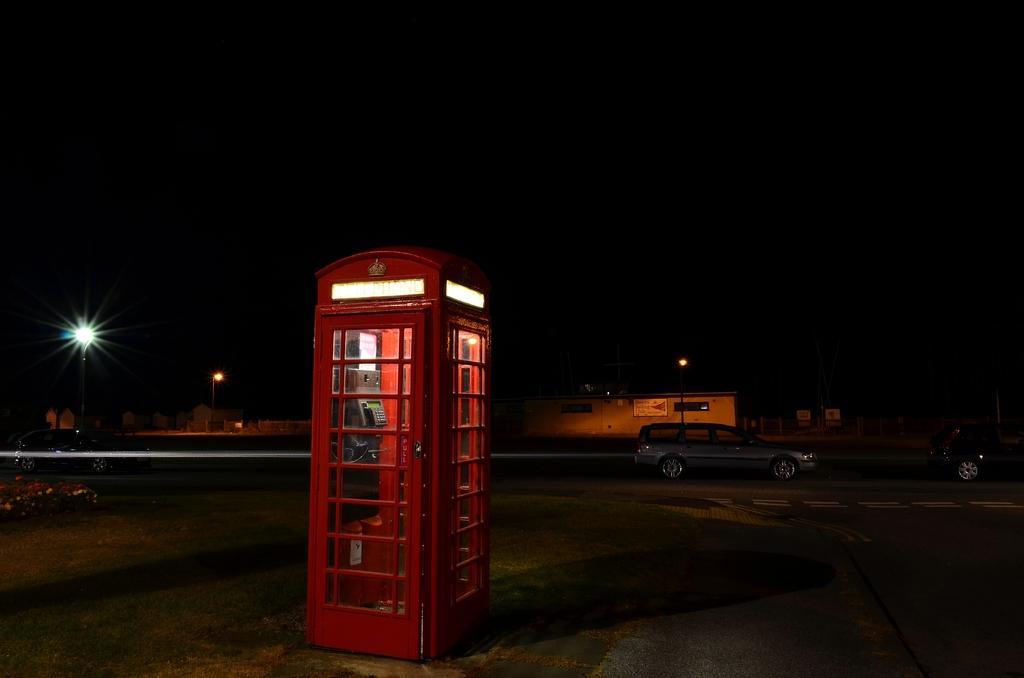How would you summarize this image in a sentence or two? In this image at the center there is a phone booth. On the backside there are cars parked on the road. On the left side of the image there are plants. In the background there are buildings and street lights. 